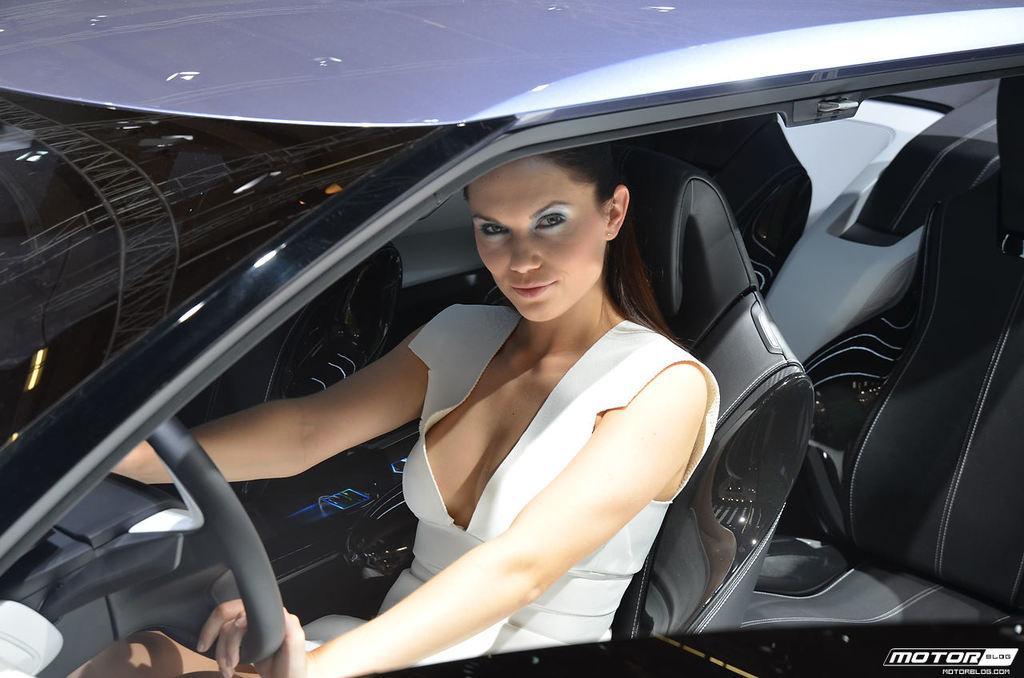Can you describe this image briefly? In the image we can see there is a car in which a woman is sitting and holding a steering wheel. 